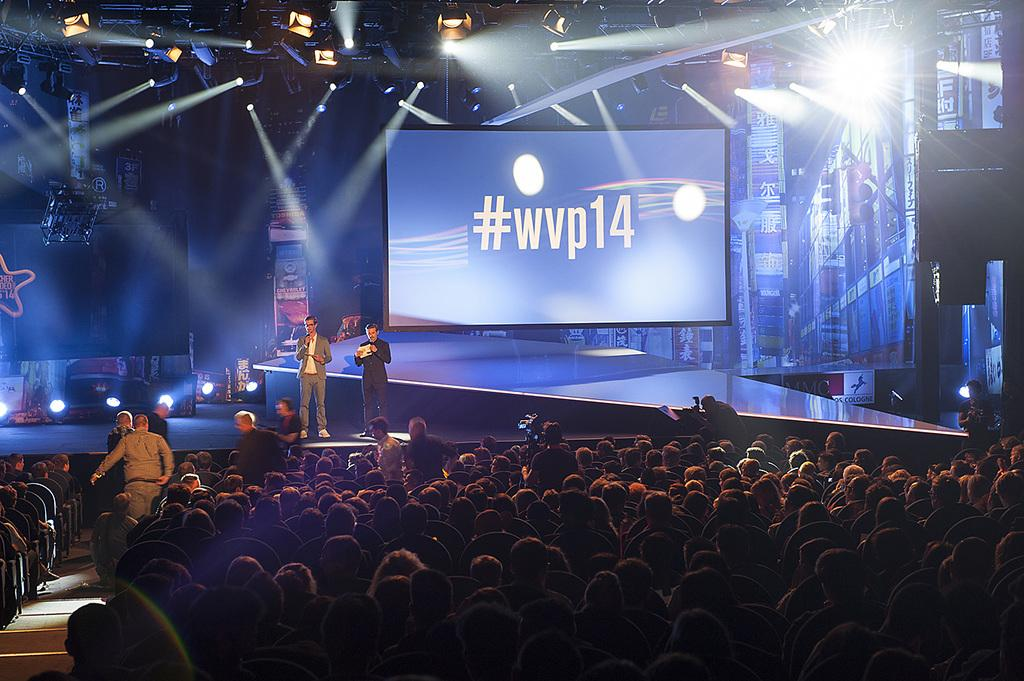<image>
Describe the image concisely. People watching a screen on the stage that says "#wvp14". 